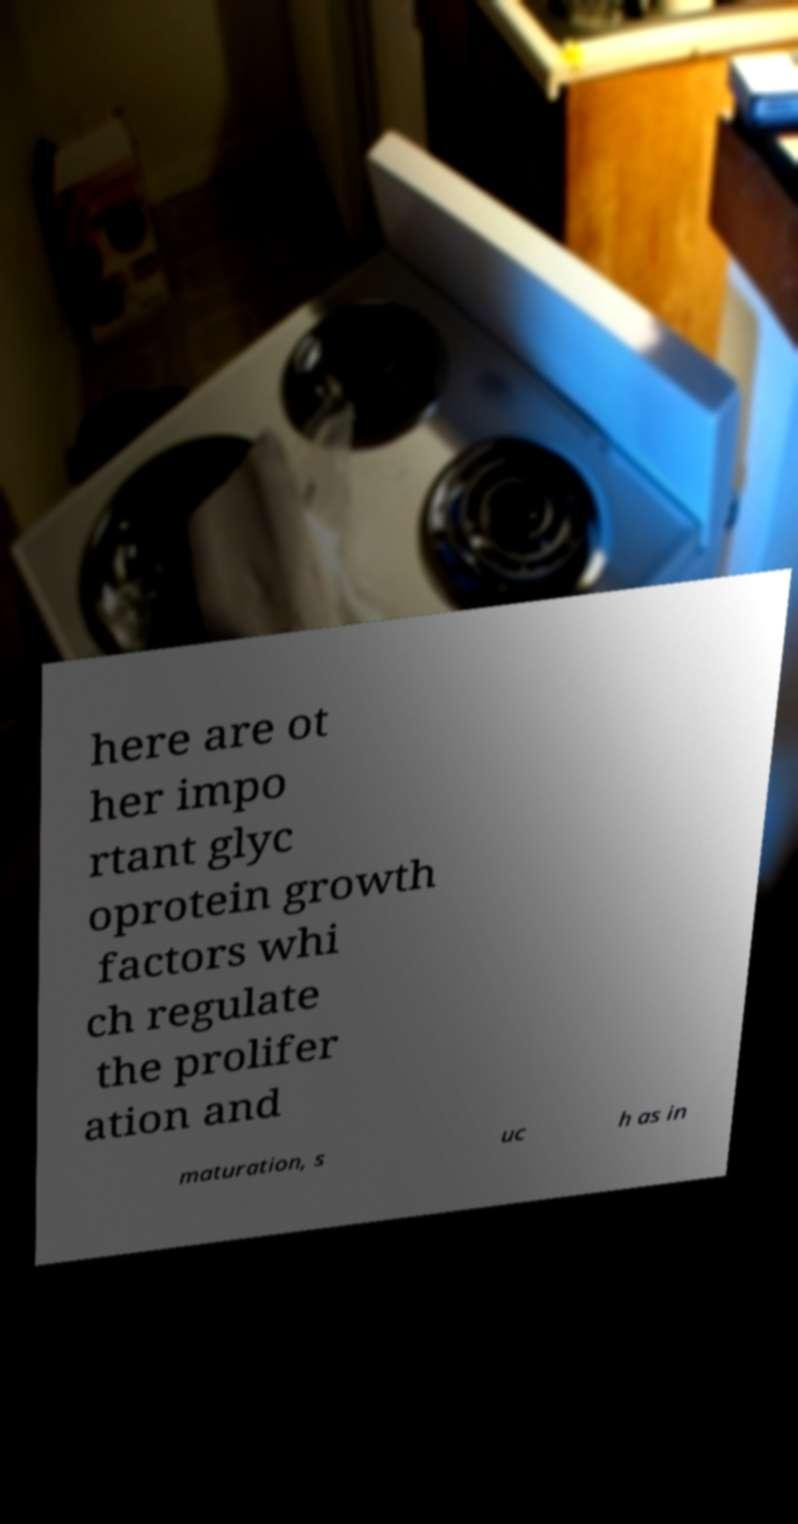I need the written content from this picture converted into text. Can you do that? here are ot her impo rtant glyc oprotein growth factors whi ch regulate the prolifer ation and maturation, s uc h as in 